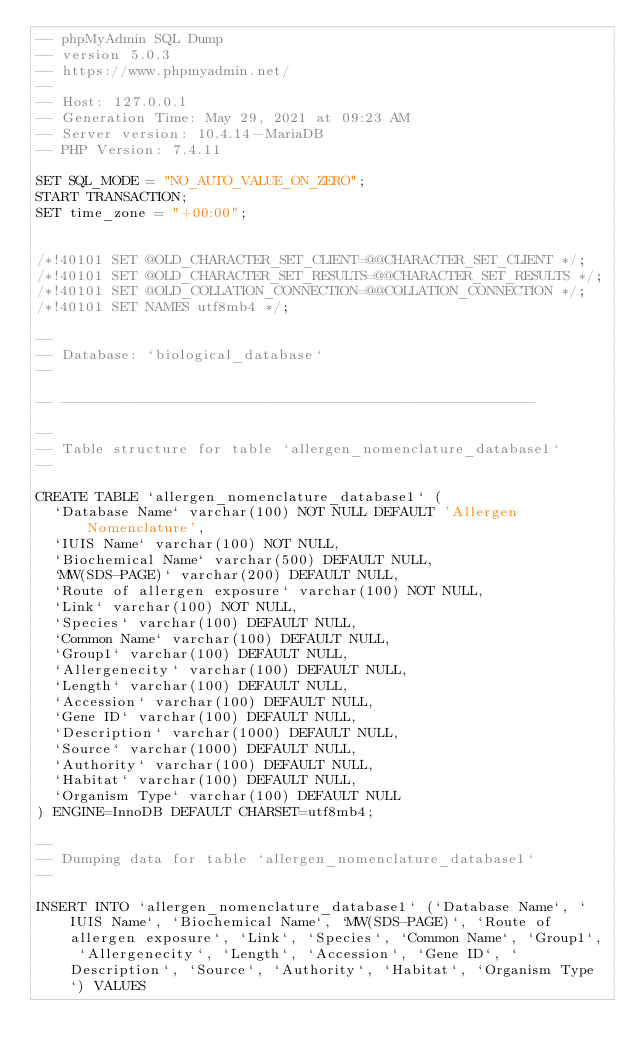<code> <loc_0><loc_0><loc_500><loc_500><_SQL_>-- phpMyAdmin SQL Dump
-- version 5.0.3
-- https://www.phpmyadmin.net/
--
-- Host: 127.0.0.1
-- Generation Time: May 29, 2021 at 09:23 AM
-- Server version: 10.4.14-MariaDB
-- PHP Version: 7.4.11

SET SQL_MODE = "NO_AUTO_VALUE_ON_ZERO";
START TRANSACTION;
SET time_zone = "+00:00";


/*!40101 SET @OLD_CHARACTER_SET_CLIENT=@@CHARACTER_SET_CLIENT */;
/*!40101 SET @OLD_CHARACTER_SET_RESULTS=@@CHARACTER_SET_RESULTS */;
/*!40101 SET @OLD_COLLATION_CONNECTION=@@COLLATION_CONNECTION */;
/*!40101 SET NAMES utf8mb4 */;

--
-- Database: `biological_database`
--

-- --------------------------------------------------------

--
-- Table structure for table `allergen_nomenclature_database1`
--

CREATE TABLE `allergen_nomenclature_database1` (
  `Database Name` varchar(100) NOT NULL DEFAULT 'Allergen Nomenclature',
  `IUIS Name` varchar(100) NOT NULL,
  `Biochemical Name` varchar(500) DEFAULT NULL,
  `MW(SDS-PAGE)` varchar(200) DEFAULT NULL,
  `Route of allergen exposure` varchar(100) NOT NULL,
  `Link` varchar(100) NOT NULL,
  `Species` varchar(100) DEFAULT NULL,
  `Common Name` varchar(100) DEFAULT NULL,
  `Group1` varchar(100) DEFAULT NULL,
  `Allergenecity` varchar(100) DEFAULT NULL,
  `Length` varchar(100) DEFAULT NULL,
  `Accession` varchar(100) DEFAULT NULL,
  `Gene ID` varchar(100) DEFAULT NULL,
  `Description` varchar(1000) DEFAULT NULL,
  `Source` varchar(1000) DEFAULT NULL,
  `Authority` varchar(100) DEFAULT NULL,
  `Habitat` varchar(100) DEFAULT NULL,
  `Organism Type` varchar(100) DEFAULT NULL
) ENGINE=InnoDB DEFAULT CHARSET=utf8mb4;

--
-- Dumping data for table `allergen_nomenclature_database1`
--

INSERT INTO `allergen_nomenclature_database1` (`Database Name`, `IUIS Name`, `Biochemical Name`, `MW(SDS-PAGE)`, `Route of allergen exposure`, `Link`, `Species`, `Common Name`, `Group1`, `Allergenecity`, `Length`, `Accession`, `Gene ID`, `Description`, `Source`, `Authority`, `Habitat`, `Organism Type`) VALUES</code> 